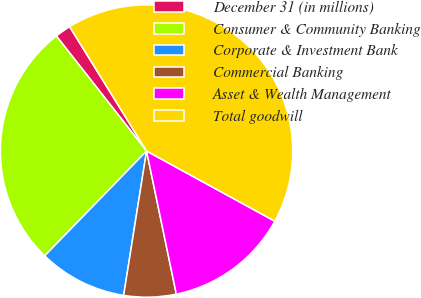Convert chart. <chart><loc_0><loc_0><loc_500><loc_500><pie_chart><fcel>December 31 (in millions)<fcel>Consumer & Community Banking<fcel>Corporate & Investment Bank<fcel>Commercial Banking<fcel>Asset & Wealth Management<fcel>Total goodwill<nl><fcel>1.77%<fcel>27.14%<fcel>9.77%<fcel>5.77%<fcel>13.77%<fcel>41.79%<nl></chart> 